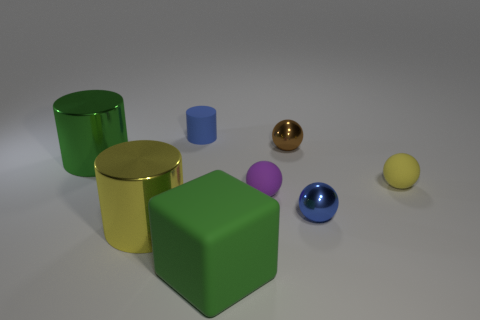Add 1 small cylinders. How many objects exist? 9 Subtract all blocks. How many objects are left? 7 Add 5 cylinders. How many cylinders exist? 8 Subtract 1 yellow spheres. How many objects are left? 7 Subtract all small objects. Subtract all tiny purple things. How many objects are left? 2 Add 8 small yellow objects. How many small yellow objects are left? 9 